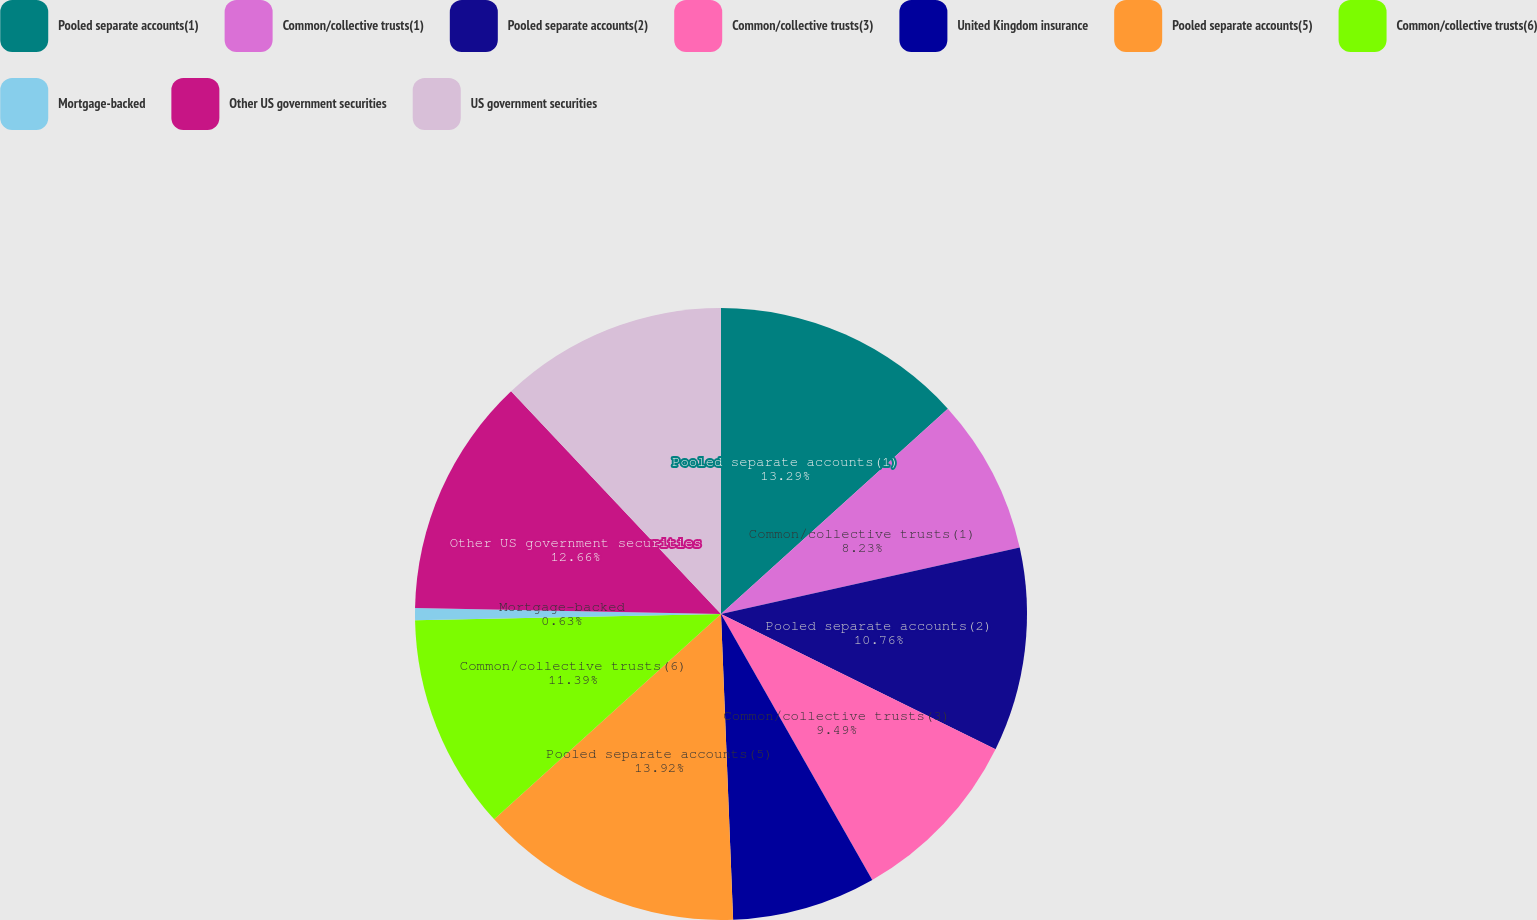Convert chart. <chart><loc_0><loc_0><loc_500><loc_500><pie_chart><fcel>Pooled separate accounts(1)<fcel>Common/collective trusts(1)<fcel>Pooled separate accounts(2)<fcel>Common/collective trusts(3)<fcel>United Kingdom insurance<fcel>Pooled separate accounts(5)<fcel>Common/collective trusts(6)<fcel>Mortgage-backed<fcel>Other US government securities<fcel>US government securities<nl><fcel>13.29%<fcel>8.23%<fcel>10.76%<fcel>9.49%<fcel>7.6%<fcel>13.92%<fcel>11.39%<fcel>0.63%<fcel>12.66%<fcel>12.03%<nl></chart> 